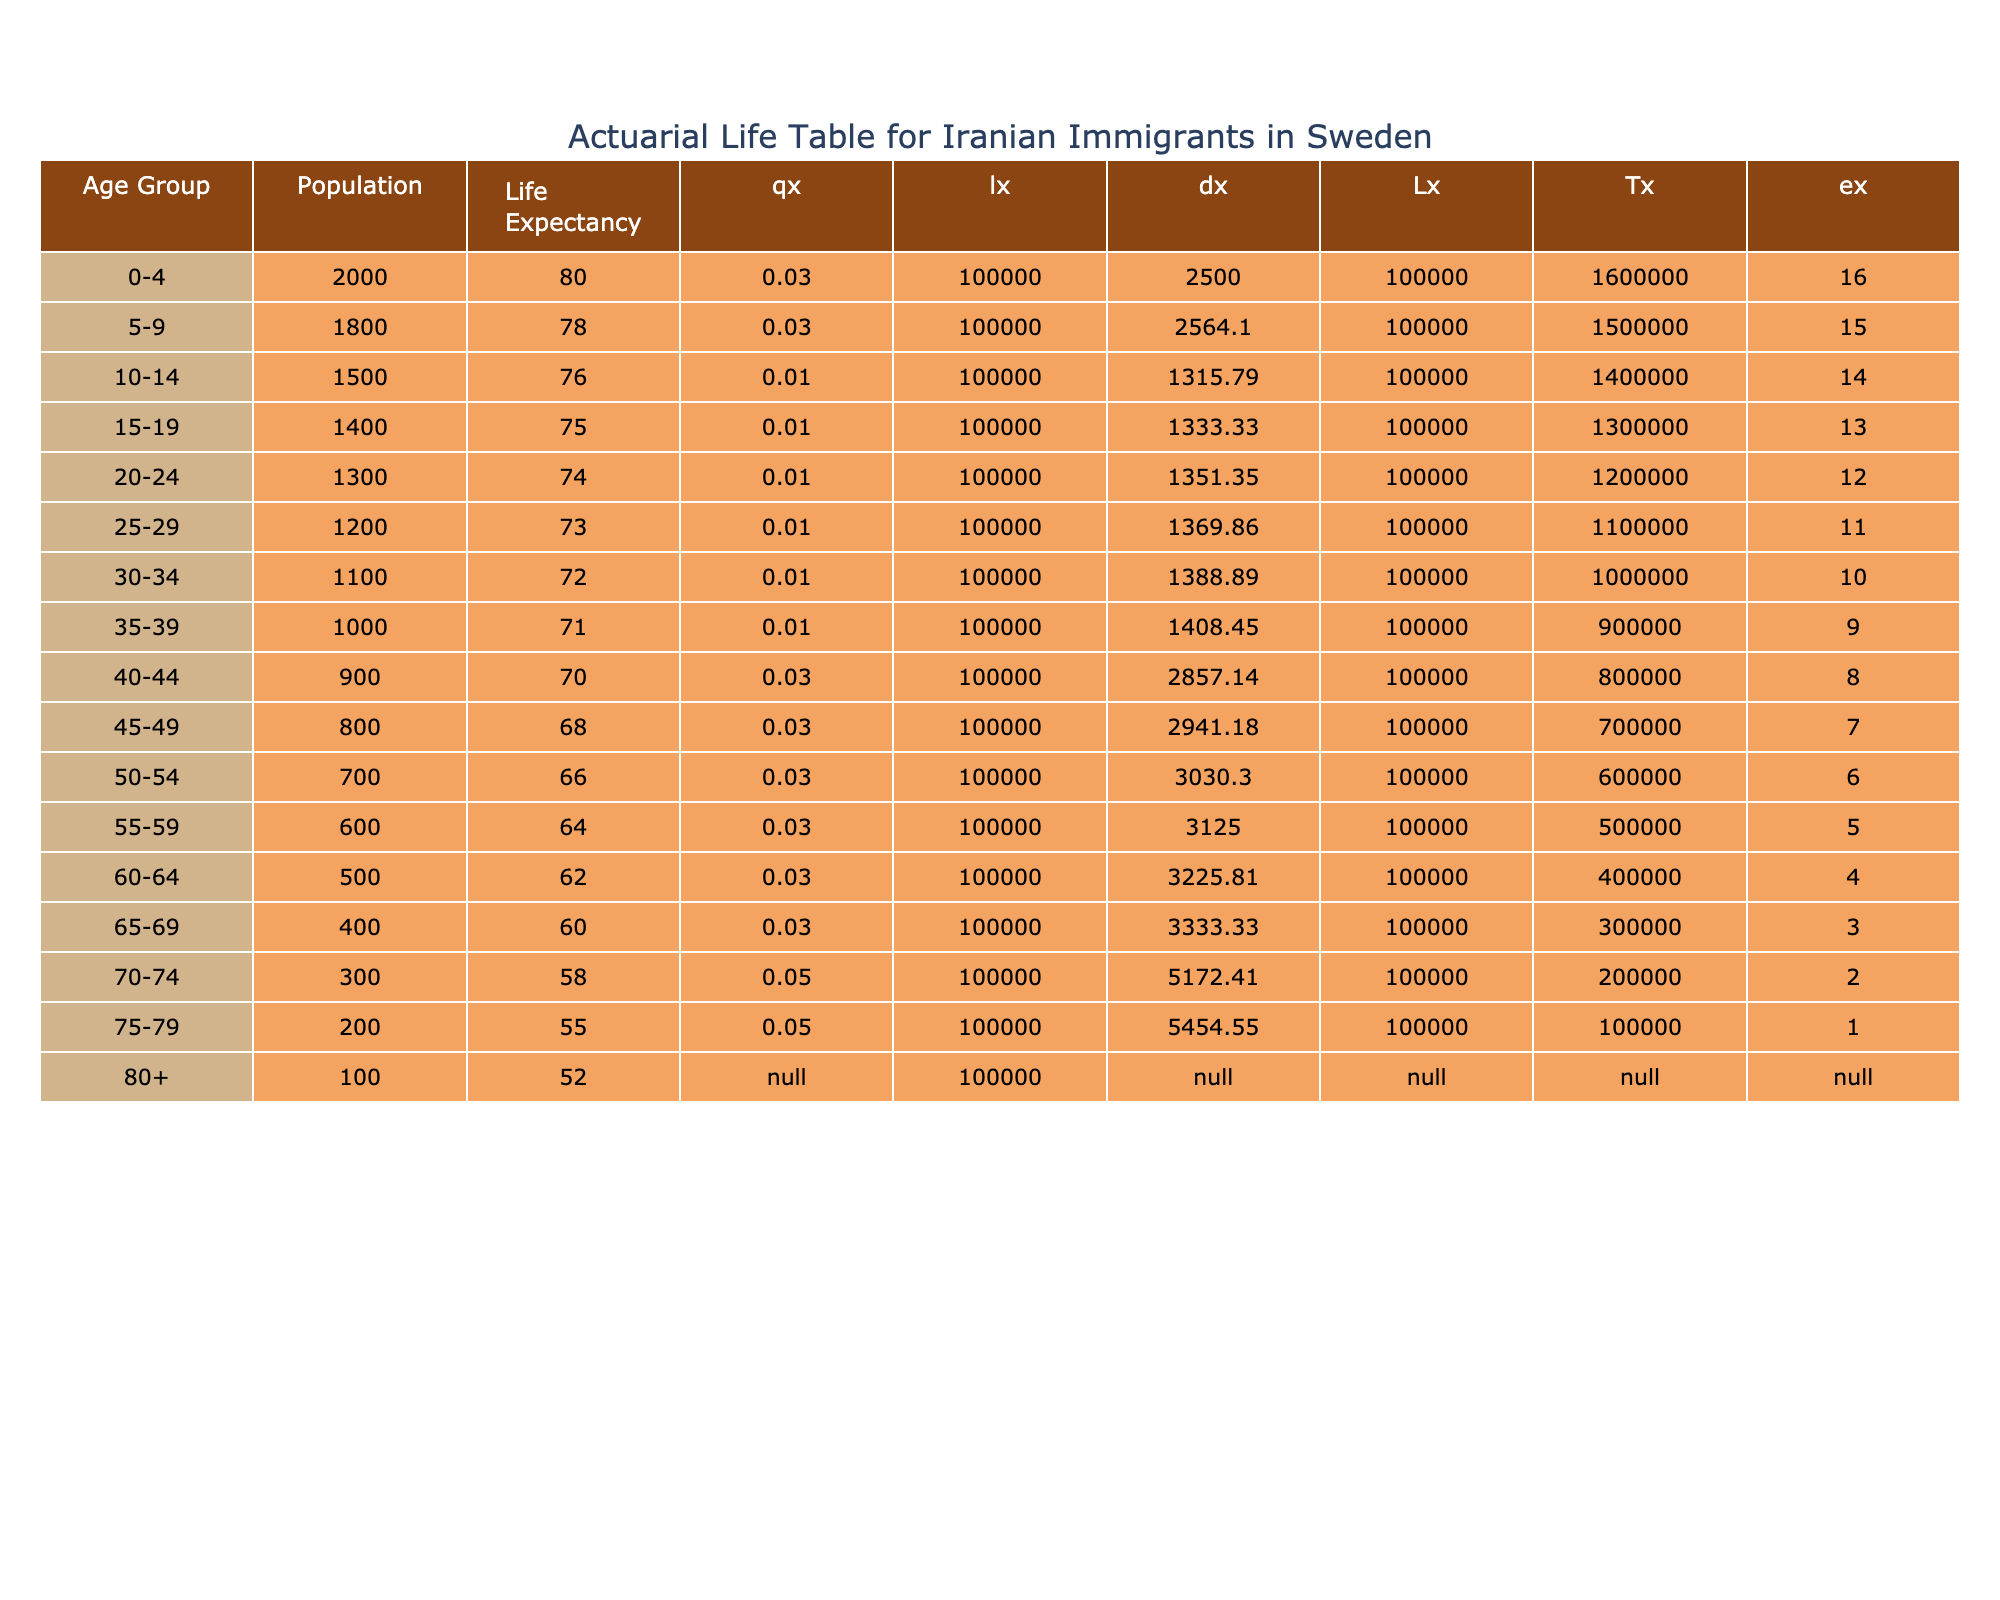What is the life expectancy of Iranian immigrants aged 70-74? The life expectancy of the age group 70-74 is directly stated in the table, which shows that for this age group, the life expectancy is 58 years.
Answer: 58 How many Iranian immigrants are there in the age group 50-54? The population for the age group 50-54 is clearly listed in the table as 700.
Answer: 700 What is the total population of Iranian immigrants aged 0-4 and 5-9 combined? To find the total population for these age groups, we add the populations: 2000 (0-4) + 1800 (5-9) = 3800.
Answer: 3800 Is the life expectancy for the age group 45-49 less than that for the age group 50-54? The life expectancy of the age group 45-49 is 68 years, while that for 50-54 is 66 years. Since 68 is greater than 66, the statement is false.
Answer: No What is the average life expectancy for Iranian immigrants aged 30-34, 35-39, and 40-44? The life expectancies for these age groups are 72, 71, and 70 years respectively. To find the average, we add these values: 72 + 71 + 70 = 213, then divide by 3, giving an average of 71.
Answer: 71 How many years does the life expectancy decrease from the age group 25-29 to 30-34? The life expectancy for the age group 25-29 is 73 years and for 30-34 it is 72 years. The difference is 73 - 72 = 1 year.
Answer: 1 Is the population of Iranian immigrants aged 75-79 greater than that of those aged 80+? The population for 75-79 is 200 and for 80+ is 100. Since 200 is greater than 100, the statement is true.
Answer: Yes What are the total years of life expectancy for the age groups 15-19 and 20-24? The life expectancies for these age groups are 75 years (15-19) and 74 years (20-24). Therefore, the total is 75 + 74 = 149 years.
Answer: 149 At which age group does the life expectancy start to fall below 70 years? From the table, the life expectancy falls below 70 years starting from the age group 40-44, which has a life expectancy of 70 years. The subsequent group, 45-49, has a life expectancy of 68 years.
Answer: 40-44 